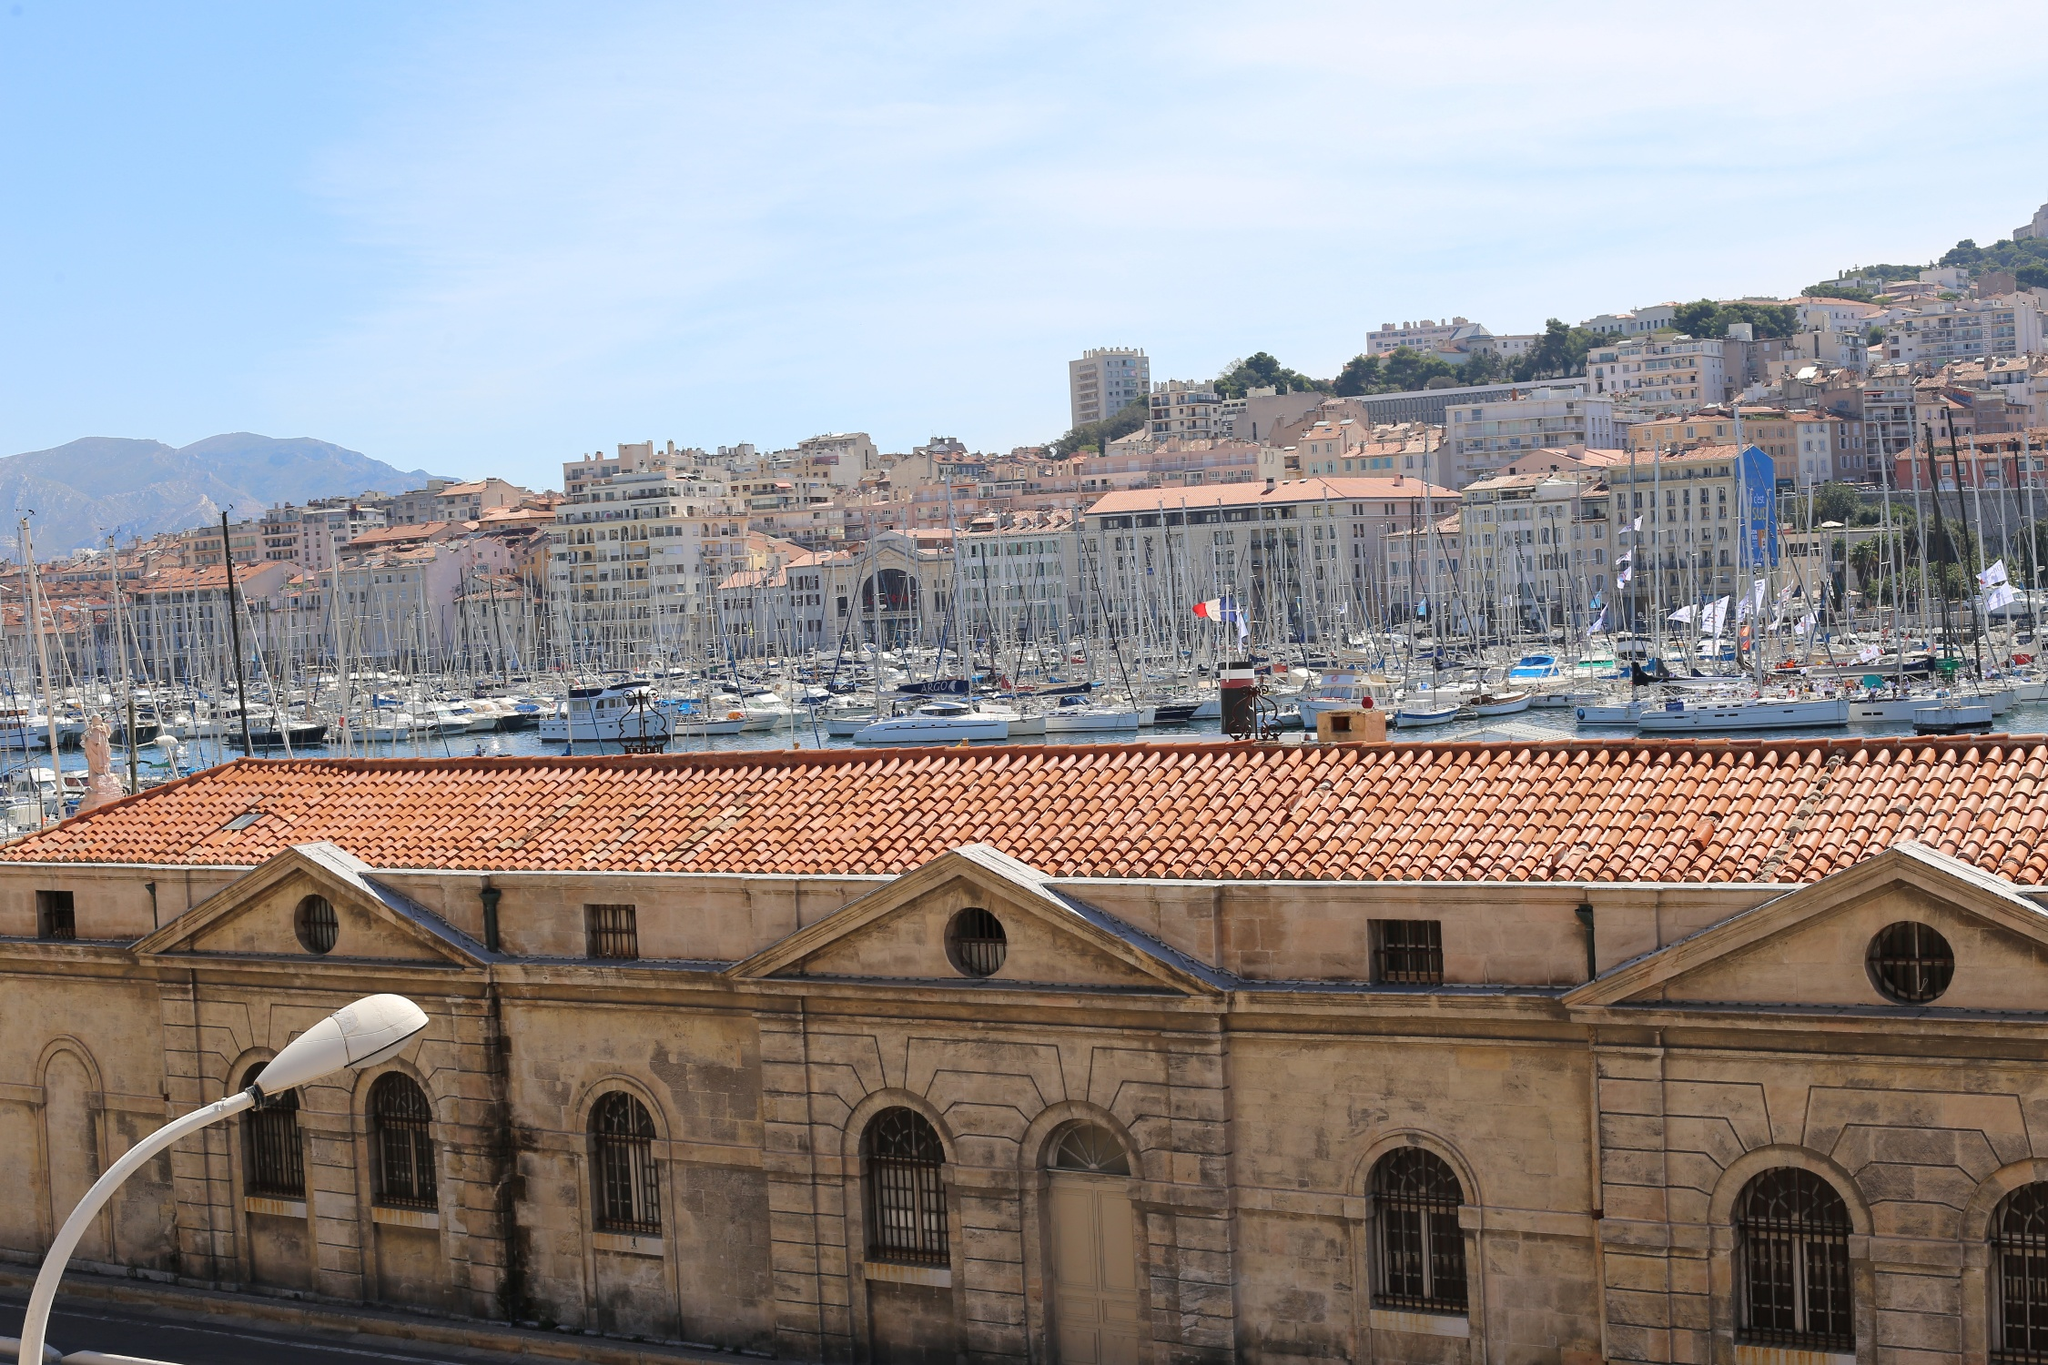Realistically, if a tourist were to have just an hour to visit this place, what are the must-see locations and activities? If a tourist only had an hour to visit the Old Port of Marseille, they should start with a quick stroll along the waterfront to soak in the vibrant atmosphere and take in the picturesque view of the boats and the Mediterranean-style buildings. A visit to the nearby fish market would give them a taste of the local maritime culture. They should not miss the chance to snap a few photos of the historic buildings and the cascading cityscape. If time allows, a brief visit to a waterfront café for a quick coffee or a local snack would add a delightful culinary touch to their visit, and they might also squeeze in a quick tour of one of the historic landmarks like the Marseille Cathedral or Fort Saint-Jean for a glimpse into the city's rich history. 